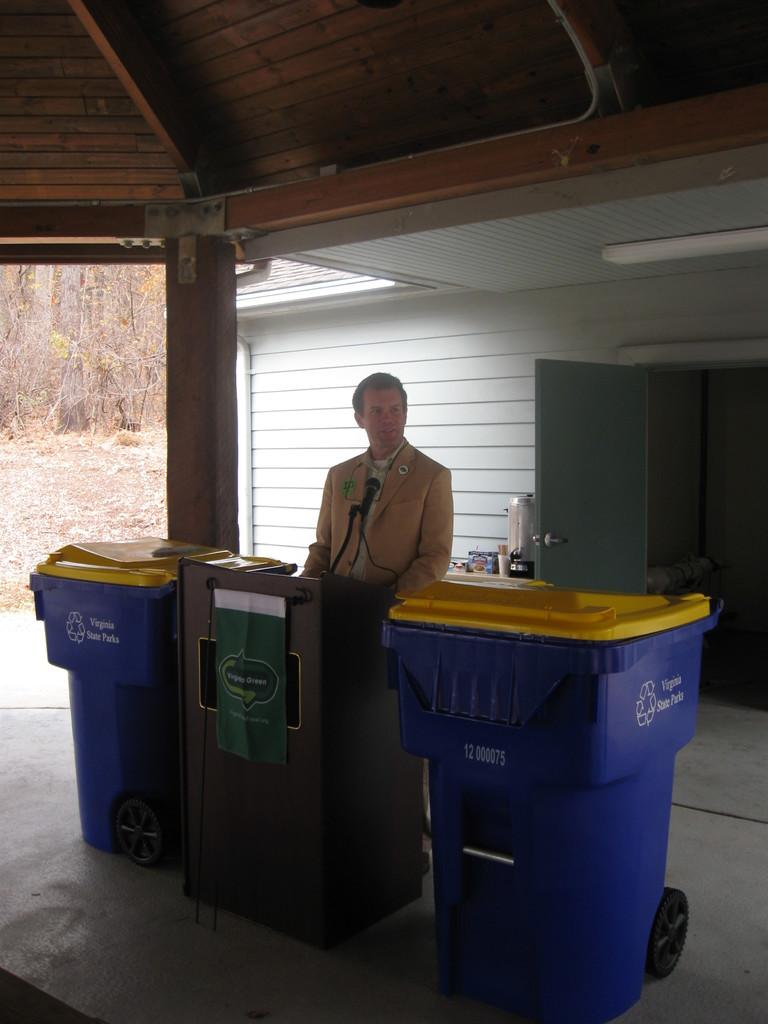<image>
Relay a brief, clear account of the picture shown. A man stands at a podium between two blue recycling bins, which read Virginia State Parks on them. 